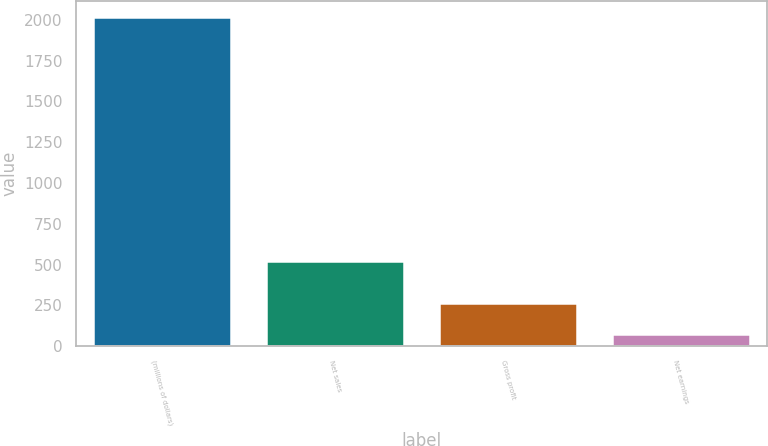Convert chart. <chart><loc_0><loc_0><loc_500><loc_500><bar_chart><fcel>(millions of dollars)<fcel>Net sales<fcel>Gross profit<fcel>Net earnings<nl><fcel>2015<fcel>519<fcel>267.47<fcel>73.3<nl></chart> 